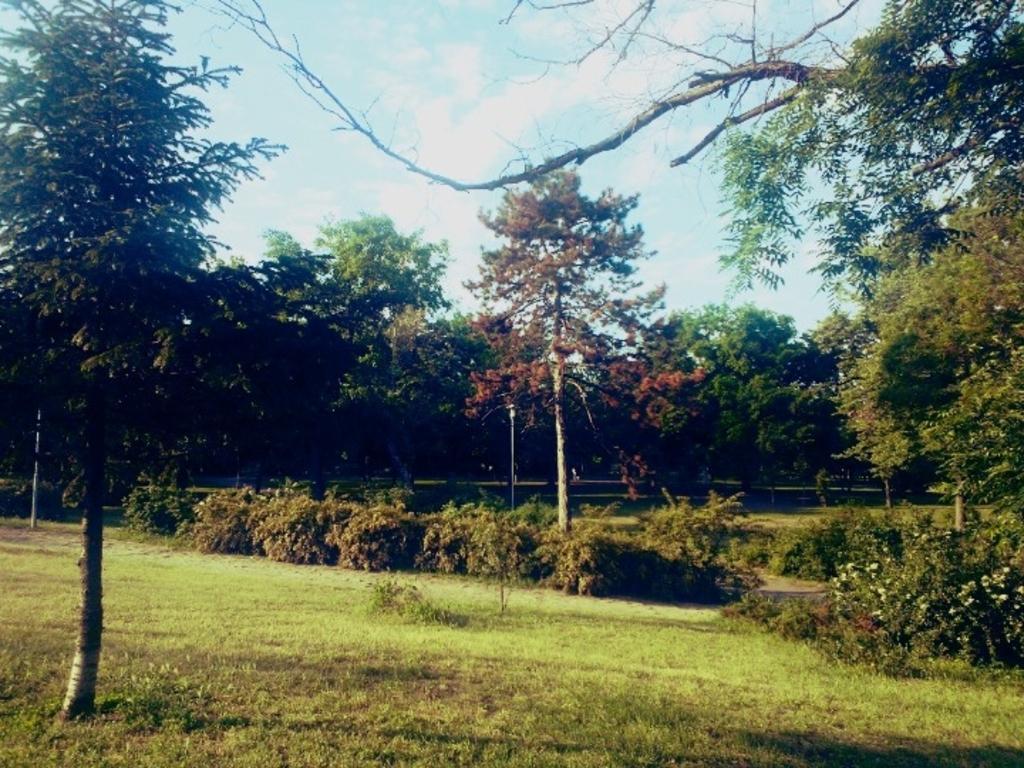Describe this image in one or two sentences. In this image we can see grass, plants, flowers, poles, and trees. In the background there is sky with clouds. 